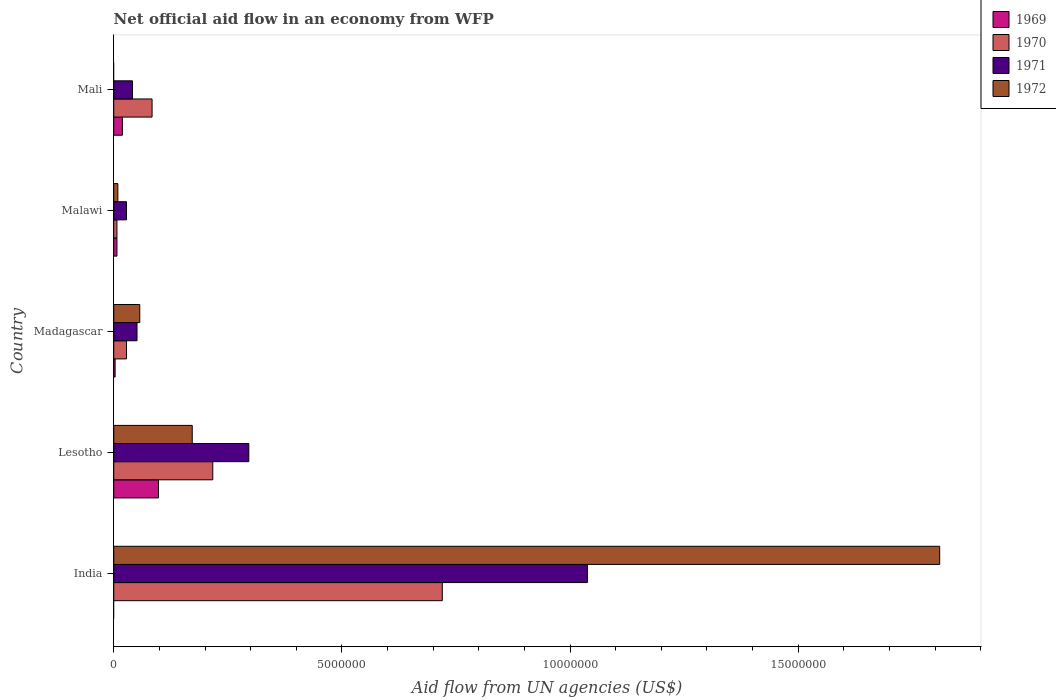How many groups of bars are there?
Provide a short and direct response. 5. Are the number of bars per tick equal to the number of legend labels?
Provide a succinct answer. No. Are the number of bars on each tick of the Y-axis equal?
Your answer should be compact. No. How many bars are there on the 1st tick from the bottom?
Keep it short and to the point. 3. What is the label of the 4th group of bars from the top?
Offer a terse response. Lesotho. In how many cases, is the number of bars for a given country not equal to the number of legend labels?
Keep it short and to the point. 2. What is the net official aid flow in 1972 in India?
Give a very brief answer. 1.81e+07. Across all countries, what is the maximum net official aid flow in 1970?
Offer a very short reply. 7.20e+06. What is the total net official aid flow in 1970 in the graph?
Offer a terse response. 1.06e+07. What is the difference between the net official aid flow in 1972 in Lesotho and that in Malawi?
Give a very brief answer. 1.63e+06. What is the average net official aid flow in 1971 per country?
Keep it short and to the point. 2.91e+06. What is the difference between the net official aid flow in 1971 and net official aid flow in 1969 in Mali?
Provide a succinct answer. 2.20e+05. In how many countries, is the net official aid flow in 1969 greater than 3000000 US$?
Provide a succinct answer. 0. What is the ratio of the net official aid flow in 1970 in India to that in Malawi?
Your response must be concise. 102.86. Is the net official aid flow in 1970 in India less than that in Malawi?
Offer a terse response. No. What is the difference between the highest and the second highest net official aid flow in 1972?
Your response must be concise. 1.64e+07. What is the difference between the highest and the lowest net official aid flow in 1970?
Make the answer very short. 7.13e+06. Is it the case that in every country, the sum of the net official aid flow in 1970 and net official aid flow in 1971 is greater than the sum of net official aid flow in 1972 and net official aid flow in 1969?
Provide a succinct answer. Yes. How many bars are there?
Make the answer very short. 18. How many countries are there in the graph?
Your answer should be very brief. 5. What is the difference between two consecutive major ticks on the X-axis?
Give a very brief answer. 5.00e+06. Are the values on the major ticks of X-axis written in scientific E-notation?
Make the answer very short. No. What is the title of the graph?
Provide a short and direct response. Net official aid flow in an economy from WFP. Does "1972" appear as one of the legend labels in the graph?
Provide a succinct answer. Yes. What is the label or title of the X-axis?
Give a very brief answer. Aid flow from UN agencies (US$). What is the label or title of the Y-axis?
Your answer should be compact. Country. What is the Aid flow from UN agencies (US$) in 1969 in India?
Give a very brief answer. 0. What is the Aid flow from UN agencies (US$) of 1970 in India?
Give a very brief answer. 7.20e+06. What is the Aid flow from UN agencies (US$) in 1971 in India?
Offer a very short reply. 1.04e+07. What is the Aid flow from UN agencies (US$) in 1972 in India?
Give a very brief answer. 1.81e+07. What is the Aid flow from UN agencies (US$) in 1969 in Lesotho?
Provide a short and direct response. 9.80e+05. What is the Aid flow from UN agencies (US$) of 1970 in Lesotho?
Offer a terse response. 2.17e+06. What is the Aid flow from UN agencies (US$) of 1971 in Lesotho?
Ensure brevity in your answer.  2.96e+06. What is the Aid flow from UN agencies (US$) in 1972 in Lesotho?
Your response must be concise. 1.72e+06. What is the Aid flow from UN agencies (US$) of 1970 in Madagascar?
Offer a terse response. 2.80e+05. What is the Aid flow from UN agencies (US$) in 1971 in Madagascar?
Your answer should be compact. 5.10e+05. What is the Aid flow from UN agencies (US$) of 1972 in Madagascar?
Offer a terse response. 5.70e+05. What is the Aid flow from UN agencies (US$) of 1970 in Mali?
Give a very brief answer. 8.40e+05. What is the Aid flow from UN agencies (US$) of 1971 in Mali?
Provide a succinct answer. 4.10e+05. What is the Aid flow from UN agencies (US$) of 1972 in Mali?
Give a very brief answer. 0. Across all countries, what is the maximum Aid flow from UN agencies (US$) in 1969?
Your answer should be very brief. 9.80e+05. Across all countries, what is the maximum Aid flow from UN agencies (US$) of 1970?
Offer a very short reply. 7.20e+06. Across all countries, what is the maximum Aid flow from UN agencies (US$) in 1971?
Offer a very short reply. 1.04e+07. Across all countries, what is the maximum Aid flow from UN agencies (US$) of 1972?
Provide a succinct answer. 1.81e+07. Across all countries, what is the minimum Aid flow from UN agencies (US$) in 1971?
Your response must be concise. 2.80e+05. Across all countries, what is the minimum Aid flow from UN agencies (US$) of 1972?
Ensure brevity in your answer.  0. What is the total Aid flow from UN agencies (US$) of 1969 in the graph?
Your response must be concise. 1.27e+06. What is the total Aid flow from UN agencies (US$) of 1970 in the graph?
Ensure brevity in your answer.  1.06e+07. What is the total Aid flow from UN agencies (US$) in 1971 in the graph?
Your response must be concise. 1.45e+07. What is the total Aid flow from UN agencies (US$) of 1972 in the graph?
Give a very brief answer. 2.05e+07. What is the difference between the Aid flow from UN agencies (US$) in 1970 in India and that in Lesotho?
Provide a short and direct response. 5.03e+06. What is the difference between the Aid flow from UN agencies (US$) of 1971 in India and that in Lesotho?
Provide a short and direct response. 7.42e+06. What is the difference between the Aid flow from UN agencies (US$) in 1972 in India and that in Lesotho?
Give a very brief answer. 1.64e+07. What is the difference between the Aid flow from UN agencies (US$) of 1970 in India and that in Madagascar?
Provide a succinct answer. 6.92e+06. What is the difference between the Aid flow from UN agencies (US$) in 1971 in India and that in Madagascar?
Your response must be concise. 9.87e+06. What is the difference between the Aid flow from UN agencies (US$) of 1972 in India and that in Madagascar?
Make the answer very short. 1.75e+07. What is the difference between the Aid flow from UN agencies (US$) in 1970 in India and that in Malawi?
Your answer should be compact. 7.13e+06. What is the difference between the Aid flow from UN agencies (US$) of 1971 in India and that in Malawi?
Keep it short and to the point. 1.01e+07. What is the difference between the Aid flow from UN agencies (US$) in 1972 in India and that in Malawi?
Keep it short and to the point. 1.80e+07. What is the difference between the Aid flow from UN agencies (US$) in 1970 in India and that in Mali?
Your answer should be very brief. 6.36e+06. What is the difference between the Aid flow from UN agencies (US$) of 1971 in India and that in Mali?
Your response must be concise. 9.97e+06. What is the difference between the Aid flow from UN agencies (US$) in 1969 in Lesotho and that in Madagascar?
Your answer should be very brief. 9.50e+05. What is the difference between the Aid flow from UN agencies (US$) of 1970 in Lesotho and that in Madagascar?
Your answer should be compact. 1.89e+06. What is the difference between the Aid flow from UN agencies (US$) of 1971 in Lesotho and that in Madagascar?
Make the answer very short. 2.45e+06. What is the difference between the Aid flow from UN agencies (US$) in 1972 in Lesotho and that in Madagascar?
Your response must be concise. 1.15e+06. What is the difference between the Aid flow from UN agencies (US$) of 1969 in Lesotho and that in Malawi?
Your answer should be very brief. 9.10e+05. What is the difference between the Aid flow from UN agencies (US$) in 1970 in Lesotho and that in Malawi?
Provide a short and direct response. 2.10e+06. What is the difference between the Aid flow from UN agencies (US$) in 1971 in Lesotho and that in Malawi?
Offer a very short reply. 2.68e+06. What is the difference between the Aid flow from UN agencies (US$) of 1972 in Lesotho and that in Malawi?
Provide a succinct answer. 1.63e+06. What is the difference between the Aid flow from UN agencies (US$) of 1969 in Lesotho and that in Mali?
Your answer should be very brief. 7.90e+05. What is the difference between the Aid flow from UN agencies (US$) of 1970 in Lesotho and that in Mali?
Your answer should be very brief. 1.33e+06. What is the difference between the Aid flow from UN agencies (US$) of 1971 in Lesotho and that in Mali?
Your answer should be very brief. 2.55e+06. What is the difference between the Aid flow from UN agencies (US$) of 1970 in Madagascar and that in Malawi?
Make the answer very short. 2.10e+05. What is the difference between the Aid flow from UN agencies (US$) in 1972 in Madagascar and that in Malawi?
Offer a very short reply. 4.80e+05. What is the difference between the Aid flow from UN agencies (US$) in 1969 in Madagascar and that in Mali?
Keep it short and to the point. -1.60e+05. What is the difference between the Aid flow from UN agencies (US$) in 1970 in Madagascar and that in Mali?
Provide a short and direct response. -5.60e+05. What is the difference between the Aid flow from UN agencies (US$) of 1971 in Madagascar and that in Mali?
Your answer should be very brief. 1.00e+05. What is the difference between the Aid flow from UN agencies (US$) in 1970 in Malawi and that in Mali?
Make the answer very short. -7.70e+05. What is the difference between the Aid flow from UN agencies (US$) of 1970 in India and the Aid flow from UN agencies (US$) of 1971 in Lesotho?
Your answer should be very brief. 4.24e+06. What is the difference between the Aid flow from UN agencies (US$) in 1970 in India and the Aid flow from UN agencies (US$) in 1972 in Lesotho?
Offer a terse response. 5.48e+06. What is the difference between the Aid flow from UN agencies (US$) of 1971 in India and the Aid flow from UN agencies (US$) of 1972 in Lesotho?
Provide a short and direct response. 8.66e+06. What is the difference between the Aid flow from UN agencies (US$) of 1970 in India and the Aid flow from UN agencies (US$) of 1971 in Madagascar?
Make the answer very short. 6.69e+06. What is the difference between the Aid flow from UN agencies (US$) in 1970 in India and the Aid flow from UN agencies (US$) in 1972 in Madagascar?
Your response must be concise. 6.63e+06. What is the difference between the Aid flow from UN agencies (US$) in 1971 in India and the Aid flow from UN agencies (US$) in 1972 in Madagascar?
Your response must be concise. 9.81e+06. What is the difference between the Aid flow from UN agencies (US$) in 1970 in India and the Aid flow from UN agencies (US$) in 1971 in Malawi?
Provide a short and direct response. 6.92e+06. What is the difference between the Aid flow from UN agencies (US$) of 1970 in India and the Aid flow from UN agencies (US$) of 1972 in Malawi?
Your answer should be compact. 7.11e+06. What is the difference between the Aid flow from UN agencies (US$) in 1971 in India and the Aid flow from UN agencies (US$) in 1972 in Malawi?
Provide a succinct answer. 1.03e+07. What is the difference between the Aid flow from UN agencies (US$) in 1970 in India and the Aid flow from UN agencies (US$) in 1971 in Mali?
Your response must be concise. 6.79e+06. What is the difference between the Aid flow from UN agencies (US$) of 1969 in Lesotho and the Aid flow from UN agencies (US$) of 1970 in Madagascar?
Give a very brief answer. 7.00e+05. What is the difference between the Aid flow from UN agencies (US$) in 1969 in Lesotho and the Aid flow from UN agencies (US$) in 1971 in Madagascar?
Provide a succinct answer. 4.70e+05. What is the difference between the Aid flow from UN agencies (US$) in 1969 in Lesotho and the Aid flow from UN agencies (US$) in 1972 in Madagascar?
Provide a short and direct response. 4.10e+05. What is the difference between the Aid flow from UN agencies (US$) in 1970 in Lesotho and the Aid flow from UN agencies (US$) in 1971 in Madagascar?
Offer a terse response. 1.66e+06. What is the difference between the Aid flow from UN agencies (US$) in 1970 in Lesotho and the Aid flow from UN agencies (US$) in 1972 in Madagascar?
Offer a very short reply. 1.60e+06. What is the difference between the Aid flow from UN agencies (US$) in 1971 in Lesotho and the Aid flow from UN agencies (US$) in 1972 in Madagascar?
Make the answer very short. 2.39e+06. What is the difference between the Aid flow from UN agencies (US$) of 1969 in Lesotho and the Aid flow from UN agencies (US$) of 1970 in Malawi?
Make the answer very short. 9.10e+05. What is the difference between the Aid flow from UN agencies (US$) of 1969 in Lesotho and the Aid flow from UN agencies (US$) of 1971 in Malawi?
Your answer should be compact. 7.00e+05. What is the difference between the Aid flow from UN agencies (US$) of 1969 in Lesotho and the Aid flow from UN agencies (US$) of 1972 in Malawi?
Make the answer very short. 8.90e+05. What is the difference between the Aid flow from UN agencies (US$) of 1970 in Lesotho and the Aid flow from UN agencies (US$) of 1971 in Malawi?
Your answer should be compact. 1.89e+06. What is the difference between the Aid flow from UN agencies (US$) in 1970 in Lesotho and the Aid flow from UN agencies (US$) in 1972 in Malawi?
Make the answer very short. 2.08e+06. What is the difference between the Aid flow from UN agencies (US$) of 1971 in Lesotho and the Aid flow from UN agencies (US$) of 1972 in Malawi?
Your response must be concise. 2.87e+06. What is the difference between the Aid flow from UN agencies (US$) in 1969 in Lesotho and the Aid flow from UN agencies (US$) in 1971 in Mali?
Provide a succinct answer. 5.70e+05. What is the difference between the Aid flow from UN agencies (US$) of 1970 in Lesotho and the Aid flow from UN agencies (US$) of 1971 in Mali?
Ensure brevity in your answer.  1.76e+06. What is the difference between the Aid flow from UN agencies (US$) in 1969 in Madagascar and the Aid flow from UN agencies (US$) in 1971 in Malawi?
Make the answer very short. -2.50e+05. What is the difference between the Aid flow from UN agencies (US$) of 1971 in Madagascar and the Aid flow from UN agencies (US$) of 1972 in Malawi?
Your response must be concise. 4.20e+05. What is the difference between the Aid flow from UN agencies (US$) in 1969 in Madagascar and the Aid flow from UN agencies (US$) in 1970 in Mali?
Provide a succinct answer. -8.10e+05. What is the difference between the Aid flow from UN agencies (US$) in 1969 in Madagascar and the Aid flow from UN agencies (US$) in 1971 in Mali?
Provide a short and direct response. -3.80e+05. What is the difference between the Aid flow from UN agencies (US$) in 1969 in Malawi and the Aid flow from UN agencies (US$) in 1970 in Mali?
Provide a short and direct response. -7.70e+05. What is the average Aid flow from UN agencies (US$) in 1969 per country?
Offer a terse response. 2.54e+05. What is the average Aid flow from UN agencies (US$) of 1970 per country?
Offer a terse response. 2.11e+06. What is the average Aid flow from UN agencies (US$) in 1971 per country?
Provide a short and direct response. 2.91e+06. What is the average Aid flow from UN agencies (US$) in 1972 per country?
Offer a terse response. 4.10e+06. What is the difference between the Aid flow from UN agencies (US$) of 1970 and Aid flow from UN agencies (US$) of 1971 in India?
Your answer should be very brief. -3.18e+06. What is the difference between the Aid flow from UN agencies (US$) in 1970 and Aid flow from UN agencies (US$) in 1972 in India?
Your answer should be compact. -1.09e+07. What is the difference between the Aid flow from UN agencies (US$) in 1971 and Aid flow from UN agencies (US$) in 1972 in India?
Offer a terse response. -7.72e+06. What is the difference between the Aid flow from UN agencies (US$) of 1969 and Aid flow from UN agencies (US$) of 1970 in Lesotho?
Make the answer very short. -1.19e+06. What is the difference between the Aid flow from UN agencies (US$) in 1969 and Aid flow from UN agencies (US$) in 1971 in Lesotho?
Ensure brevity in your answer.  -1.98e+06. What is the difference between the Aid flow from UN agencies (US$) in 1969 and Aid flow from UN agencies (US$) in 1972 in Lesotho?
Your answer should be very brief. -7.40e+05. What is the difference between the Aid flow from UN agencies (US$) in 1970 and Aid flow from UN agencies (US$) in 1971 in Lesotho?
Your response must be concise. -7.90e+05. What is the difference between the Aid flow from UN agencies (US$) of 1970 and Aid flow from UN agencies (US$) of 1972 in Lesotho?
Your answer should be very brief. 4.50e+05. What is the difference between the Aid flow from UN agencies (US$) of 1971 and Aid flow from UN agencies (US$) of 1972 in Lesotho?
Provide a short and direct response. 1.24e+06. What is the difference between the Aid flow from UN agencies (US$) of 1969 and Aid flow from UN agencies (US$) of 1971 in Madagascar?
Keep it short and to the point. -4.80e+05. What is the difference between the Aid flow from UN agencies (US$) in 1969 and Aid flow from UN agencies (US$) in 1972 in Madagascar?
Provide a short and direct response. -5.40e+05. What is the difference between the Aid flow from UN agencies (US$) of 1970 and Aid flow from UN agencies (US$) of 1971 in Madagascar?
Offer a very short reply. -2.30e+05. What is the difference between the Aid flow from UN agencies (US$) in 1970 and Aid flow from UN agencies (US$) in 1972 in Madagascar?
Give a very brief answer. -2.90e+05. What is the difference between the Aid flow from UN agencies (US$) in 1971 and Aid flow from UN agencies (US$) in 1972 in Madagascar?
Keep it short and to the point. -6.00e+04. What is the difference between the Aid flow from UN agencies (US$) in 1969 and Aid flow from UN agencies (US$) in 1970 in Malawi?
Provide a succinct answer. 0. What is the difference between the Aid flow from UN agencies (US$) of 1969 and Aid flow from UN agencies (US$) of 1971 in Malawi?
Your answer should be very brief. -2.10e+05. What is the difference between the Aid flow from UN agencies (US$) in 1969 and Aid flow from UN agencies (US$) in 1972 in Malawi?
Keep it short and to the point. -2.00e+04. What is the difference between the Aid flow from UN agencies (US$) of 1970 and Aid flow from UN agencies (US$) of 1972 in Malawi?
Offer a very short reply. -2.00e+04. What is the difference between the Aid flow from UN agencies (US$) of 1971 and Aid flow from UN agencies (US$) of 1972 in Malawi?
Provide a succinct answer. 1.90e+05. What is the difference between the Aid flow from UN agencies (US$) in 1969 and Aid flow from UN agencies (US$) in 1970 in Mali?
Your answer should be very brief. -6.50e+05. What is the difference between the Aid flow from UN agencies (US$) of 1970 and Aid flow from UN agencies (US$) of 1971 in Mali?
Provide a short and direct response. 4.30e+05. What is the ratio of the Aid flow from UN agencies (US$) of 1970 in India to that in Lesotho?
Keep it short and to the point. 3.32. What is the ratio of the Aid flow from UN agencies (US$) of 1971 in India to that in Lesotho?
Give a very brief answer. 3.51. What is the ratio of the Aid flow from UN agencies (US$) of 1972 in India to that in Lesotho?
Your response must be concise. 10.52. What is the ratio of the Aid flow from UN agencies (US$) of 1970 in India to that in Madagascar?
Your answer should be compact. 25.71. What is the ratio of the Aid flow from UN agencies (US$) of 1971 in India to that in Madagascar?
Your answer should be very brief. 20.35. What is the ratio of the Aid flow from UN agencies (US$) in 1972 in India to that in Madagascar?
Your response must be concise. 31.75. What is the ratio of the Aid flow from UN agencies (US$) of 1970 in India to that in Malawi?
Provide a short and direct response. 102.86. What is the ratio of the Aid flow from UN agencies (US$) in 1971 in India to that in Malawi?
Ensure brevity in your answer.  37.07. What is the ratio of the Aid flow from UN agencies (US$) in 1972 in India to that in Malawi?
Your response must be concise. 201.11. What is the ratio of the Aid flow from UN agencies (US$) of 1970 in India to that in Mali?
Your answer should be compact. 8.57. What is the ratio of the Aid flow from UN agencies (US$) of 1971 in India to that in Mali?
Offer a terse response. 25.32. What is the ratio of the Aid flow from UN agencies (US$) of 1969 in Lesotho to that in Madagascar?
Your answer should be compact. 32.67. What is the ratio of the Aid flow from UN agencies (US$) in 1970 in Lesotho to that in Madagascar?
Your response must be concise. 7.75. What is the ratio of the Aid flow from UN agencies (US$) of 1971 in Lesotho to that in Madagascar?
Your response must be concise. 5.8. What is the ratio of the Aid flow from UN agencies (US$) of 1972 in Lesotho to that in Madagascar?
Make the answer very short. 3.02. What is the ratio of the Aid flow from UN agencies (US$) in 1969 in Lesotho to that in Malawi?
Your response must be concise. 14. What is the ratio of the Aid flow from UN agencies (US$) in 1971 in Lesotho to that in Malawi?
Provide a succinct answer. 10.57. What is the ratio of the Aid flow from UN agencies (US$) in 1972 in Lesotho to that in Malawi?
Make the answer very short. 19.11. What is the ratio of the Aid flow from UN agencies (US$) in 1969 in Lesotho to that in Mali?
Provide a short and direct response. 5.16. What is the ratio of the Aid flow from UN agencies (US$) in 1970 in Lesotho to that in Mali?
Give a very brief answer. 2.58. What is the ratio of the Aid flow from UN agencies (US$) in 1971 in Lesotho to that in Mali?
Make the answer very short. 7.22. What is the ratio of the Aid flow from UN agencies (US$) in 1969 in Madagascar to that in Malawi?
Make the answer very short. 0.43. What is the ratio of the Aid flow from UN agencies (US$) in 1971 in Madagascar to that in Malawi?
Provide a succinct answer. 1.82. What is the ratio of the Aid flow from UN agencies (US$) of 1972 in Madagascar to that in Malawi?
Your response must be concise. 6.33. What is the ratio of the Aid flow from UN agencies (US$) of 1969 in Madagascar to that in Mali?
Your answer should be compact. 0.16. What is the ratio of the Aid flow from UN agencies (US$) in 1970 in Madagascar to that in Mali?
Keep it short and to the point. 0.33. What is the ratio of the Aid flow from UN agencies (US$) of 1971 in Madagascar to that in Mali?
Offer a very short reply. 1.24. What is the ratio of the Aid flow from UN agencies (US$) of 1969 in Malawi to that in Mali?
Give a very brief answer. 0.37. What is the ratio of the Aid flow from UN agencies (US$) of 1970 in Malawi to that in Mali?
Keep it short and to the point. 0.08. What is the ratio of the Aid flow from UN agencies (US$) of 1971 in Malawi to that in Mali?
Your response must be concise. 0.68. What is the difference between the highest and the second highest Aid flow from UN agencies (US$) of 1969?
Provide a short and direct response. 7.90e+05. What is the difference between the highest and the second highest Aid flow from UN agencies (US$) of 1970?
Keep it short and to the point. 5.03e+06. What is the difference between the highest and the second highest Aid flow from UN agencies (US$) of 1971?
Your answer should be compact. 7.42e+06. What is the difference between the highest and the second highest Aid flow from UN agencies (US$) in 1972?
Give a very brief answer. 1.64e+07. What is the difference between the highest and the lowest Aid flow from UN agencies (US$) of 1969?
Your answer should be very brief. 9.80e+05. What is the difference between the highest and the lowest Aid flow from UN agencies (US$) of 1970?
Make the answer very short. 7.13e+06. What is the difference between the highest and the lowest Aid flow from UN agencies (US$) in 1971?
Offer a terse response. 1.01e+07. What is the difference between the highest and the lowest Aid flow from UN agencies (US$) in 1972?
Give a very brief answer. 1.81e+07. 